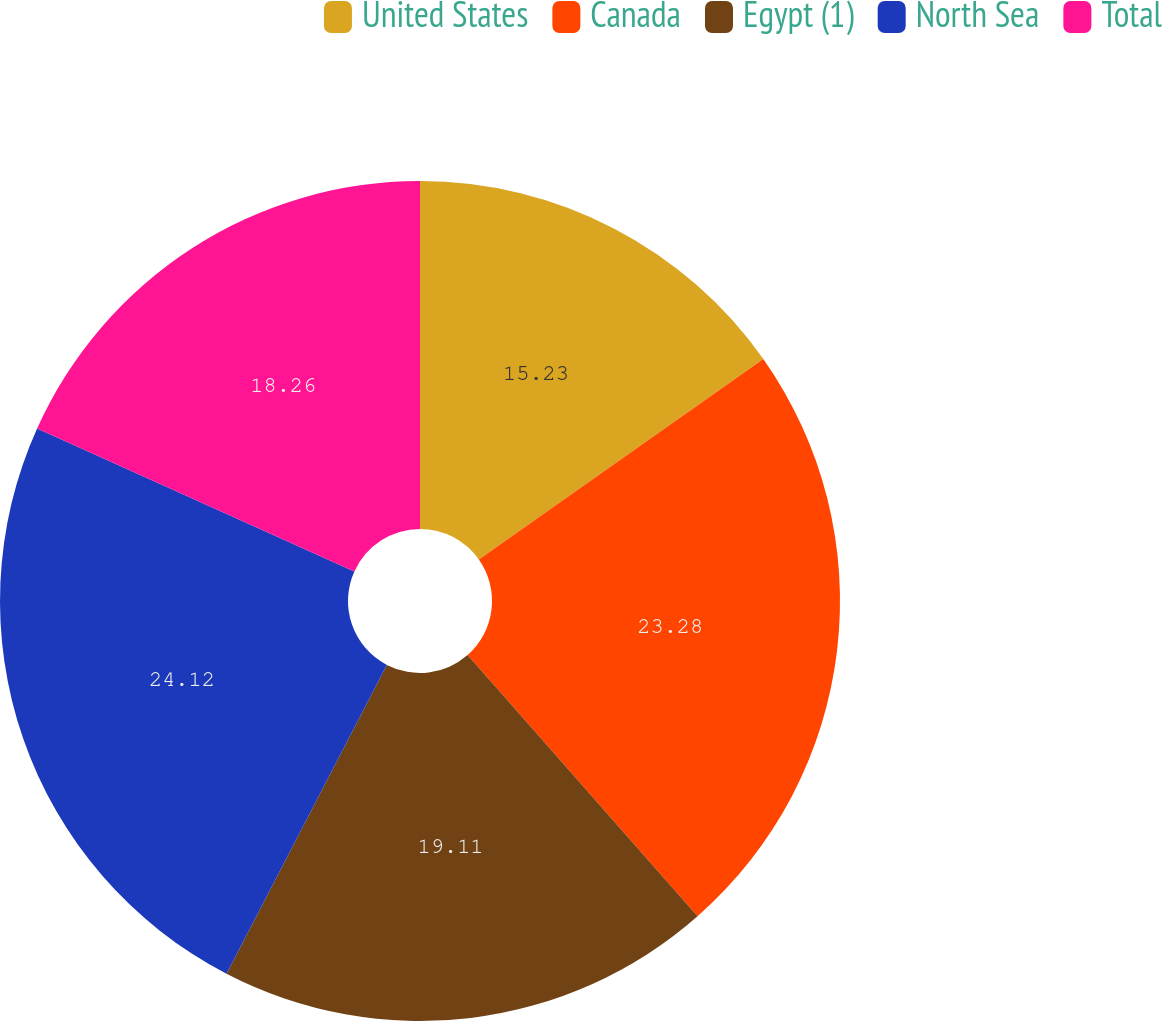<chart> <loc_0><loc_0><loc_500><loc_500><pie_chart><fcel>United States<fcel>Canada<fcel>Egypt (1)<fcel>North Sea<fcel>Total<nl><fcel>15.23%<fcel>23.28%<fcel>19.11%<fcel>24.12%<fcel>18.26%<nl></chart> 